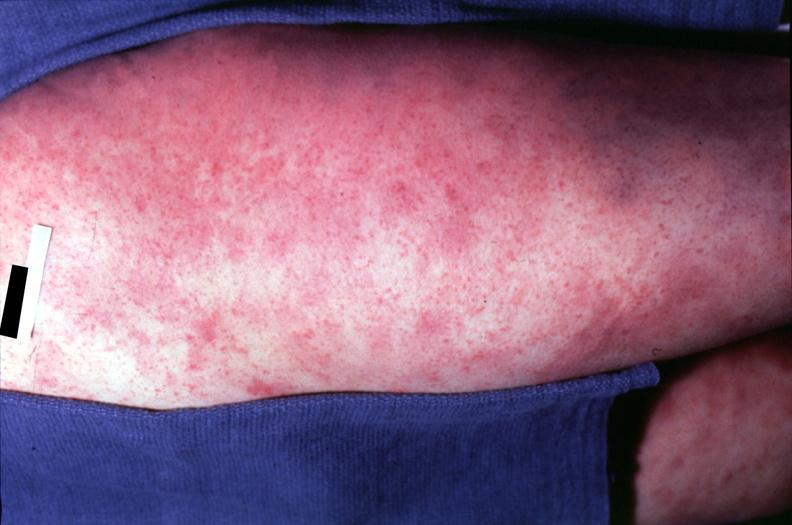does this image show skin?
Answer the question using a single word or phrase. Yes 